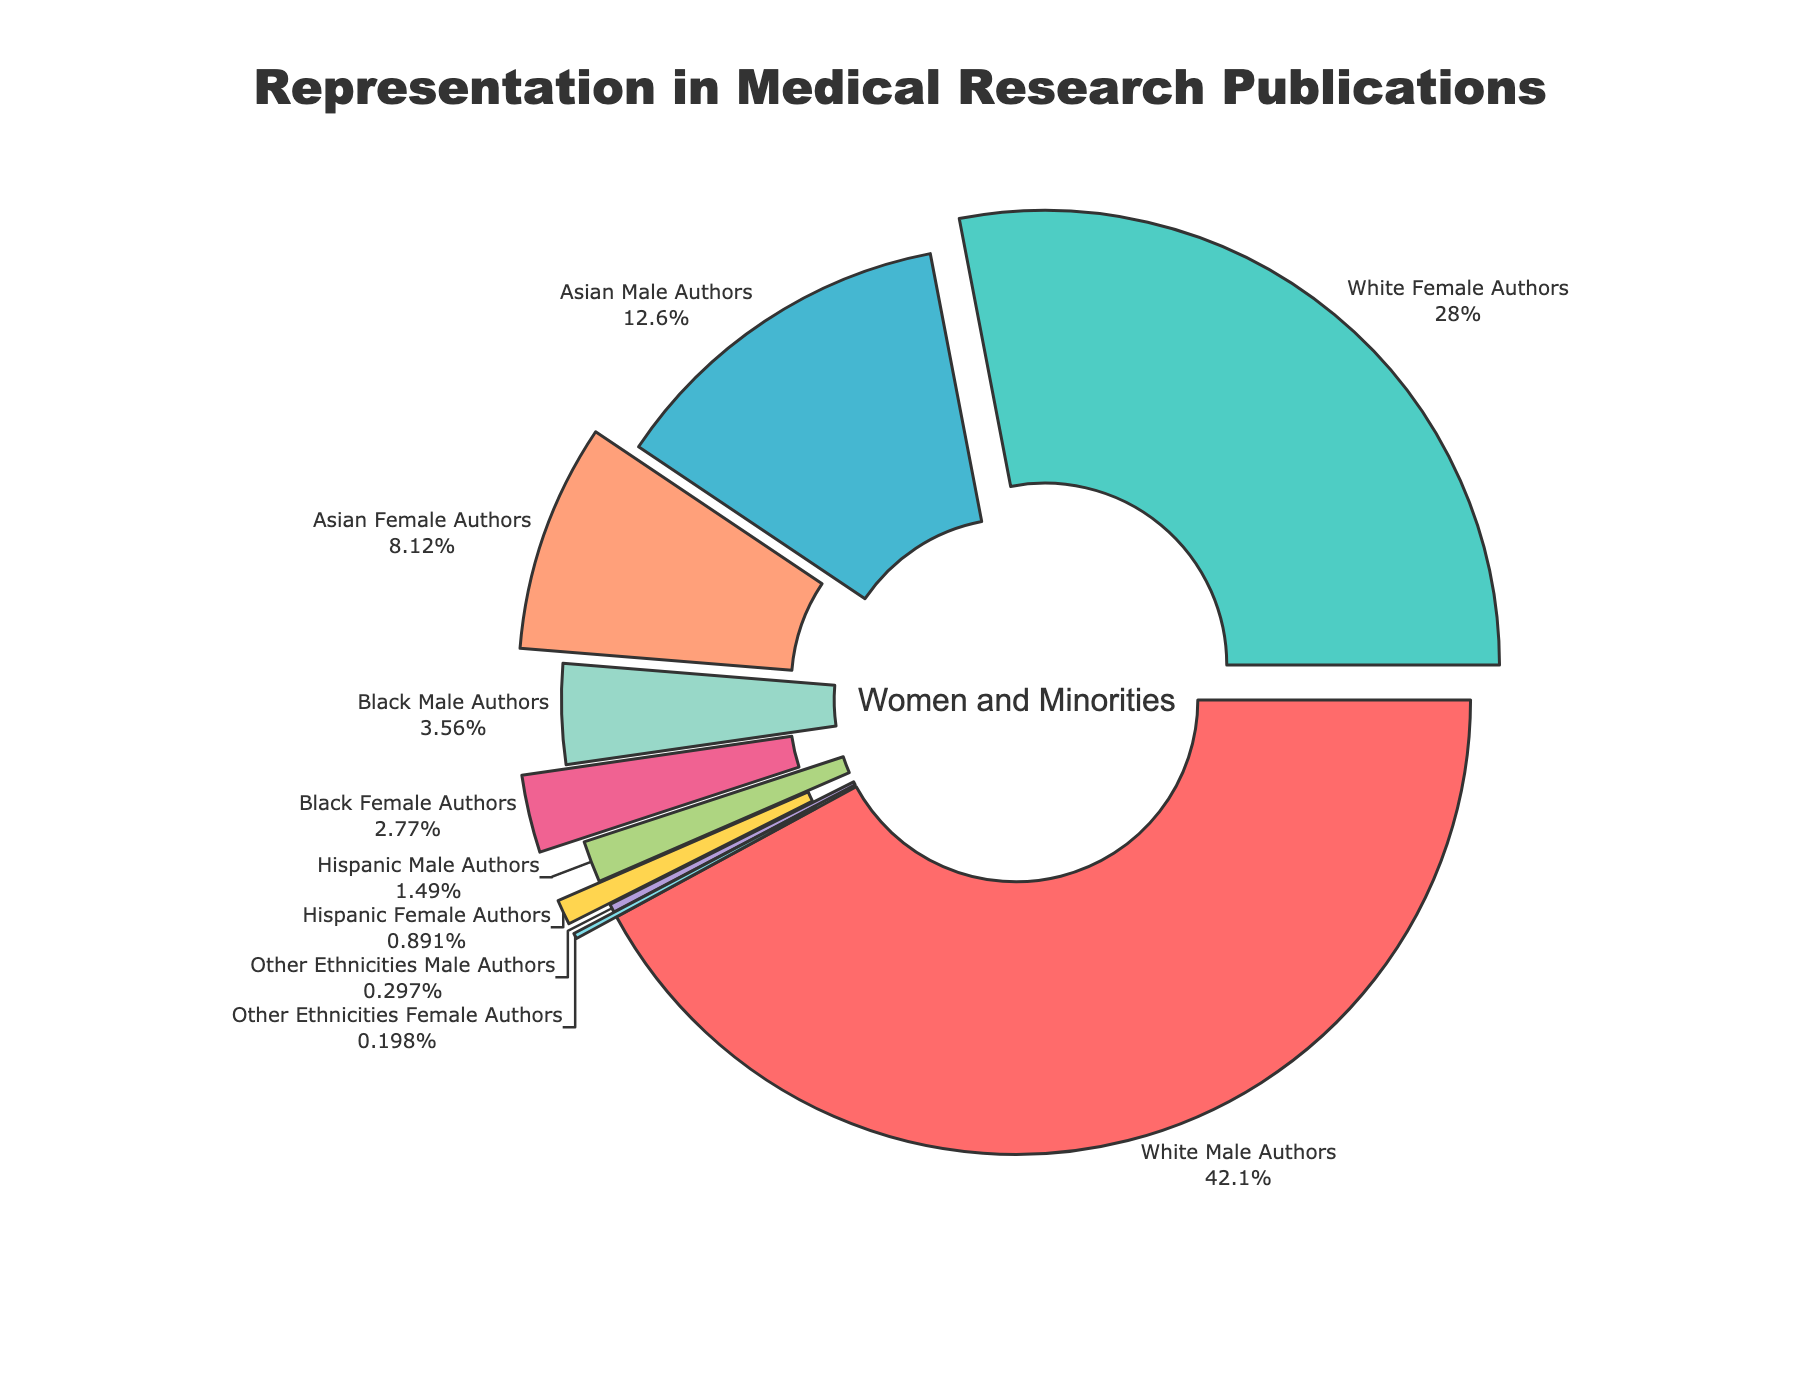What percentage of authors are white females? By referring to the pie chart, we see a segment labeled "White Female Authors" with the percentage directly displayed in the figure.
Answer: 28.3% Which group has the least representation in the medical research publications? By comparing all the segments in the pie chart based on their labeled percentages, the smallest segment is labeled as "Other Ethnicities Female Authors" with 0.2%.
Answer: Other Ethnicities Female Authors What is the difference in representation between Asian male authors and Black male authors? Asian male authors have 12.7%, and Black male authors have 3.6%. The difference is calculated by subtracting the smaller percentage from the larger percentage (12.7% - 3.6%).
Answer: 9.1% What is the combined percentage of all female authors? Sum of percentages of all female segments: White Female Authors (28.3%), Asian Female Authors (8.2%), Black Female Authors (2.8%), Hispanic Female Authors (0.9%), Other Ethnicities Female Authors (0.2%). Calculate: 28.3 + 8.2 + 2.8 + 0.9 + 0.2 = 40.4%.
Answer: 40.4% How does the representation of Hispanic authors compare between males and females? Hispanic Male Authors have 1.5%, and Hispanic Female Authors have 0.9%. We compare these values directly to see that males have a higher percentage than females.
Answer: Hispanic Male Authors > Hispanic Female Authors What percentage of authors are from Asian ethnicities? Adding the percentages for Asian Male Authors (12.7%) and Asian Female Authors (8.2%). Calculate: 12.7 + 8.2 = 20.9%.
Answer: 20.9% How does the representation of white males compare to the combined representation of all ethnicities female authors? White Male Authors have 42.5%. To find the combined percentage of all ethnicities female authors: (White Female Authors (28.3%) + Asian Female Authors (8.2%) + Black Female Authors (2.8%) + Hispanic Female Authors (0.9%) + Other Ethnicities Female Authors (0.2%)). Calculate: 28.3 + 8.2 + 2.8 + 0.9 + 0.2 = 40.4%. Thus, 40.4% compared against 42.5%.
Answer: White Male Authors > Combined Female Authors Which gender has higher overall representation, male or female? Combine all male authors: White Male (42.5%), Asian Male (12.7%), Black Male (3.6%), Hispanic Male (1.5%), Other Ethnicities Male (0.3%). Calculate: 42.5 + 12.7 + 3.6 + 1.5 + 0.3 = 60.6%. For females, sum all female percentages: White Female (28.3%), Asian Female (8.2%), Black Female (2.8%), Hispanic Female (0.9%), Other Ethnicities Female (0.2%). Calculate: 28.3 + 8.2 + 2.8 + 0.9 + 0.2 = 40.4%.
Answer: Males What is the total representation percentage of Black and Hispanic authors combined? Adding percentages for Black Male Authors (3.6%), Black Female Authors (2.8%), Hispanic Male Authors (1.5%), and Hispanic Female Authors (0.9%). Calculate: 3.6 + 2.8 + 1.5 + 0.9 = 8.8%.
Answer: 8.8% 